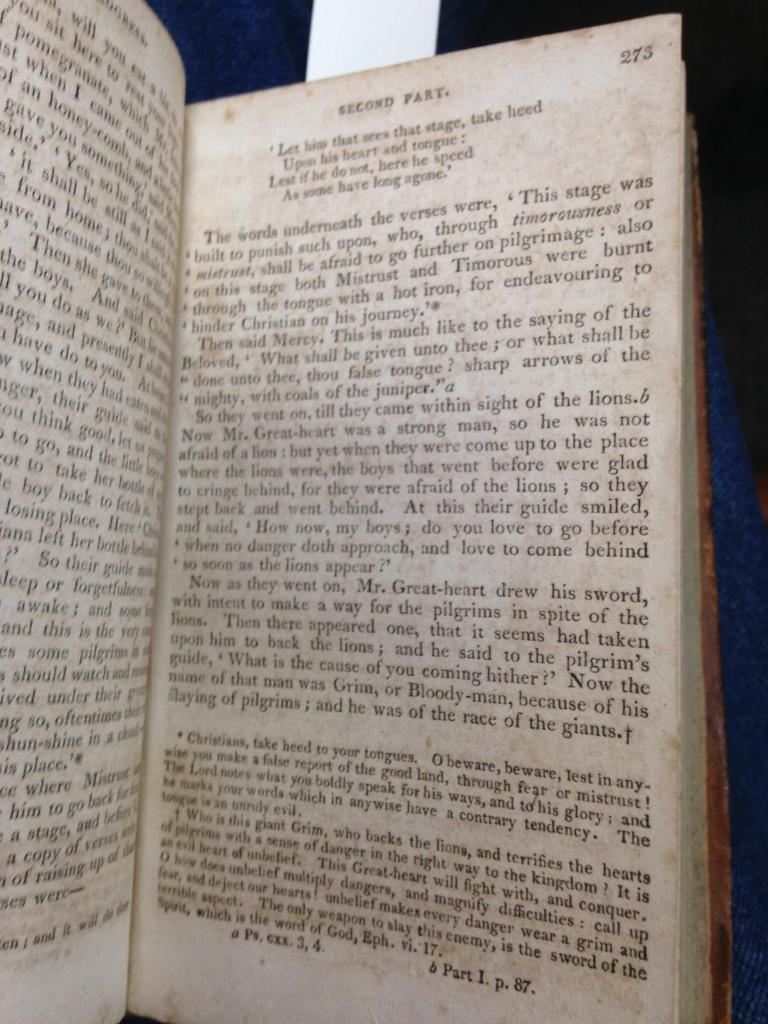Provide a one-sentence caption for the provided image. A book is open to page 273 of the second part. 